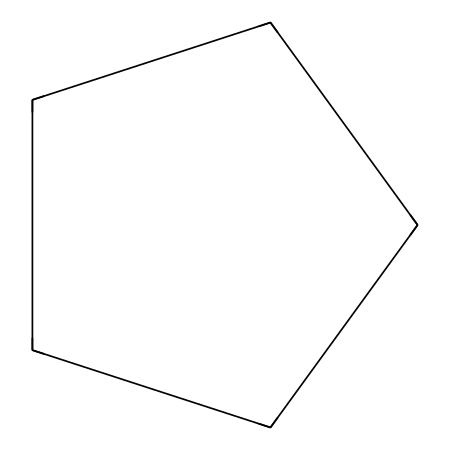What is the molecular formula of cyclopentane? By analyzing the SMILES notation C1CCCC1, we see that there are five carbon atoms denoted by 'C' and they are connected in a cyclic manner. Each carbon typically bonds with two hydrogen atoms, yielding a total of ten hydrogen atoms for five carbons. The formula is thus C5H10.
Answer: C5H10 How many carbon atoms are in cyclopentane? The SMILES representation C1CCCC1 indicates that there are five 'C' atoms present in the structure.
Answer: 5 What type of structure does cyclopentane have? The 'C1' and closing 'C1' in the SMILES notation indicates a ring formation, confirming that cyclopentane is a cyclic structure.
Answer: cyclic How many hydrogen atoms are attached to each carbon in cyclopentane? In cyclopentane, each carbon typically bonds with two hydrogen atoms due to its saturated nature. Therefore, the number of hydrogen atoms attached to each carbon is two.
Answer: 2 What distinguishes cyclopentane as a cycloalkane? Cycloalkanes are characterized by their ring structures composed solely of carbon atoms. The presence of this cyclic arrangement (shown by C1 and C1 in the SMILES) confirms that cyclopentane fits this definition as it has a cyclic structure.
Answer: cyclic structure What is the degree of saturation in cyclopentane? Cyclopentane is fully saturated (does not contain double or triple bonds), which is a characteristic of cycloalkanes. This indicates that all carbon atoms form single bonds only, leading to a degree of saturation of zero.
Answer: zero Which property of cyclopentane makes it useful in cleaning products? Cyclopentane is a non-polar solvent with good solvency properties, which makes it effective in dissolving oils and greases, thus its utility in cleaning products.
Answer: non-polar solvent 